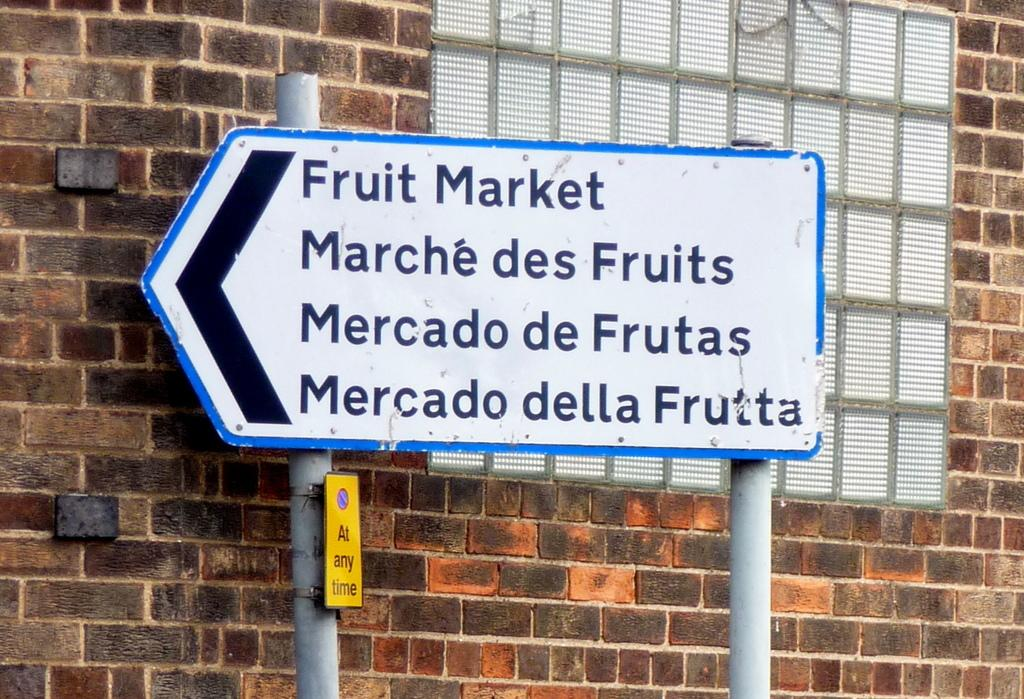<image>
Offer a succinct explanation of the picture presented. A white sign says fruit market with a small yellow sign below it. 